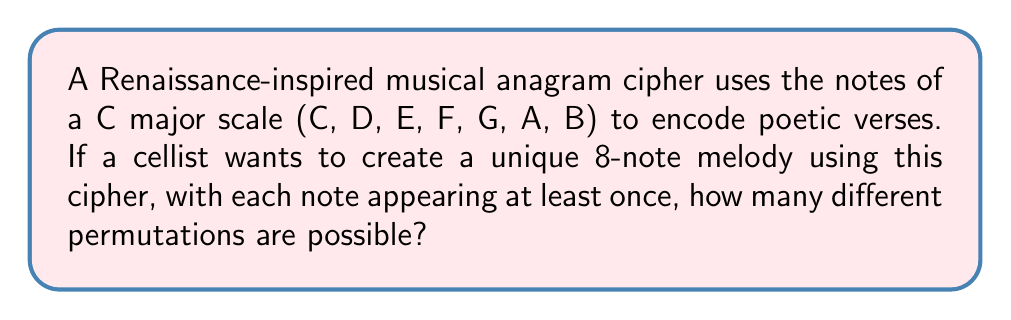Can you solve this math problem? Let's approach this step-by-step:

1) We have 7 distinct notes (C, D, E, F, G, A, B) and need to create an 8-note melody.

2) Since each note must appear at least once, we know that 7 positions will be filled by the 7 distinct notes. The 8th position can be any of the 7 notes repeated.

3) This scenario can be solved using the multiplication principle and permutations:

   a) First, we need to calculate the number of ways to arrange the 7 distinct notes in 7 positions:
      This is a straightforward permutation: $P(7,7) = 7! = 5040$

   b) Then, for the 8th position, we have 7 choices (any of the 7 notes can be repeated):
      $7$ choices

   c) By the multiplication principle, we multiply these together:

      $$ 7! \times 7 = 5040 \times 7 = 35280 $$

Therefore, there are 35,280 possible unique 8-note melodies that satisfy the given conditions.
Answer: 35,280 